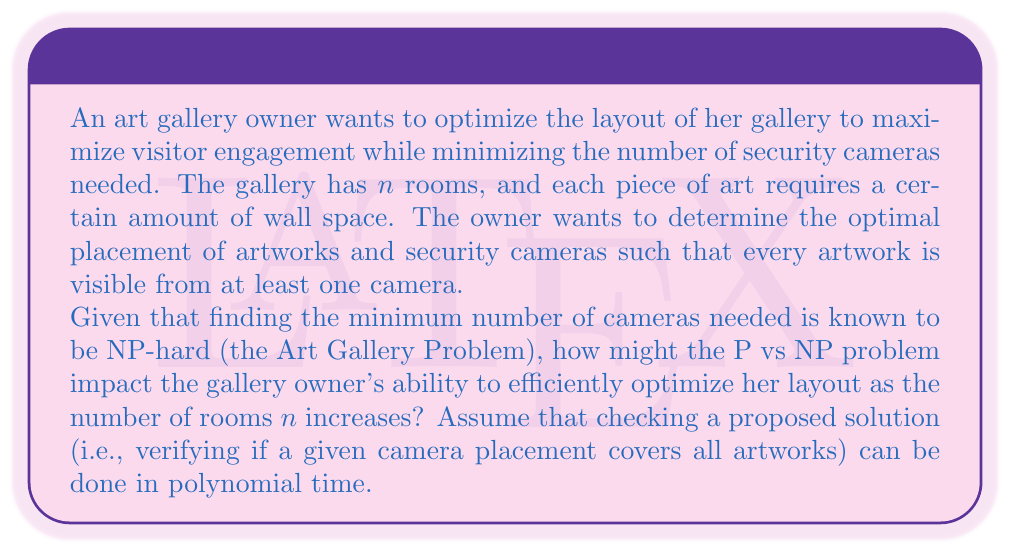Give your solution to this math problem. To understand the impact of the P vs NP problem on optimizing the art gallery layout, let's break down the problem:

1. The Art Gallery Problem is NP-hard, meaning it's at least as hard as any problem in NP.

2. The decision version of this problem (Can we cover all artworks with $k$ or fewer cameras?) is in NP because we can verify a proposed solution in polynomial time.

3. If P = NP, then there would exist a polynomial-time algorithm to solve the Art Gallery Problem optimally. This would mean:

   a. The gallery owner could efficiently find the optimal camera placement for any number of rooms $n$ in a reasonable amount of time.
   
   b. The time complexity would be something like $O(n^c)$ for some constant $c$, which grows much more slowly than exponential algorithms.

4. If P ≠ NP (which most researchers believe to be the case), then:

   a. No polynomial-time algorithm exists to solve the Art Gallery Problem optimally.
   
   b. As $n$ increases, the time to find the optimal solution would grow exponentially, making it impractical for large galleries.

5. In the P ≠ NP scenario, the gallery owner would have to resort to:

   a. Approximation algorithms that find near-optimal solutions in polynomial time.
   
   b. Heuristic approaches that work well in practice but don't guarantee optimality.
   
   c. Solving the problem optimally only for small instances and using those solutions as guidelines for larger layouts.

6. The impact on the gallery owner's workflow:

   a. For small galleries (small $n$), she could still find optimal solutions in reasonable time.
   
   b. For large galleries, she would need to balance solution quality with computation time, potentially sacrificing optimality for practicality.

7. This scenario illustrates the real-world implications of the P vs NP problem:

   a. If P = NP, many seemingly intractable problems become efficiently solvable.
   
   b. If P ≠ NP, we must often settle for approximations or heuristics for NP-hard problems in practical applications.

In the context of the art gallery, the P vs NP problem directly affects the owner's ability to optimize her layout efficiently as the gallery grows, highlighting the importance of computational complexity in real-world optimization scenarios.
Answer: If P ≠ NP (the widely believed scenario), as the number of rooms $n$ in the art gallery increases, the time required to find the optimal layout would grow exponentially, making it computationally infeasible for large galleries. The gallery owner would need to resort to approximation algorithms, heuristics, or solving optimal layouts only for smaller subsections of the gallery, balancing solution quality with practical time constraints. 